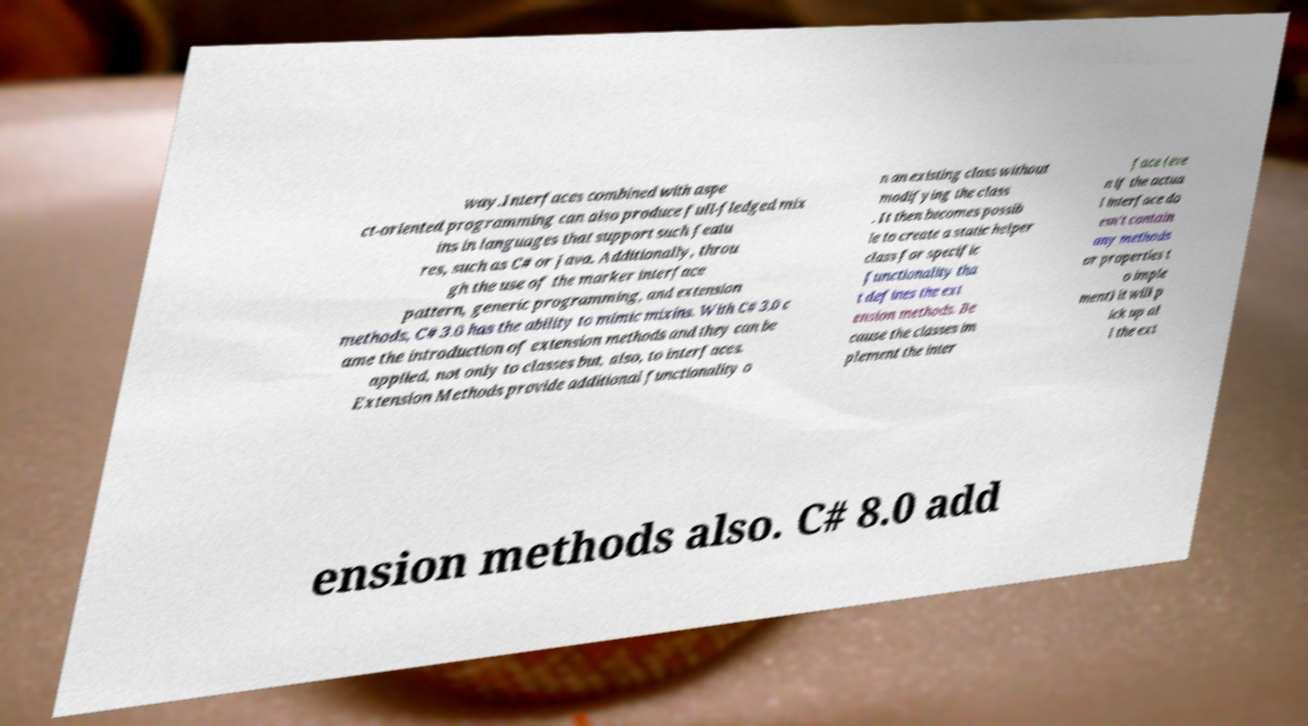Please identify and transcribe the text found in this image. way.Interfaces combined with aspe ct-oriented programming can also produce full-fledged mix ins in languages that support such featu res, such as C# or Java. Additionally, throu gh the use of the marker interface pattern, generic programming, and extension methods, C# 3.0 has the ability to mimic mixins. With C# 3.0 c ame the introduction of extension methods and they can be applied, not only to classes but, also, to interfaces. Extension Methods provide additional functionality o n an existing class without modifying the class . It then becomes possib le to create a static helper class for specific functionality tha t defines the ext ension methods. Be cause the classes im plement the inter face (eve n if the actua l interface do esn’t contain any methods or properties t o imple ment) it will p ick up al l the ext ension methods also. C# 8.0 add 